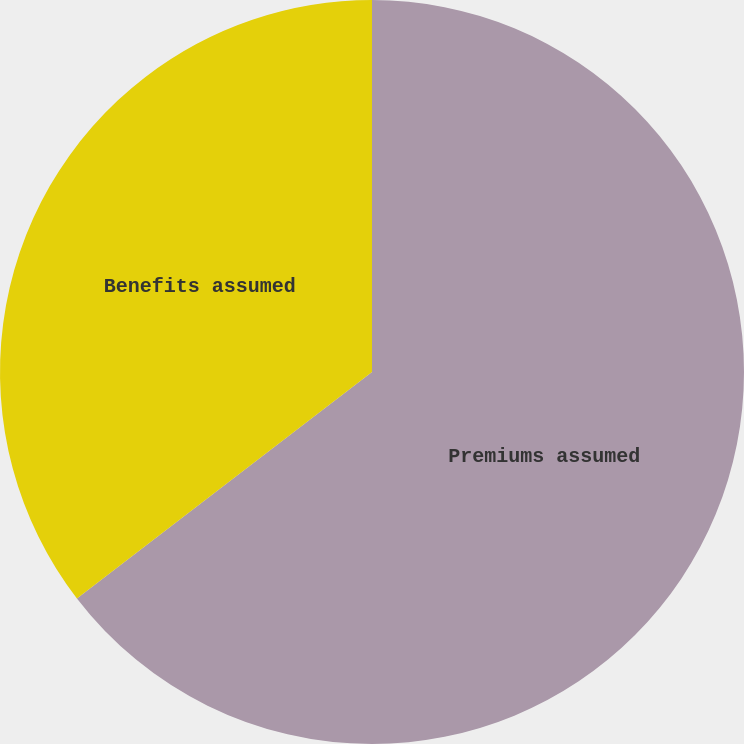Convert chart. <chart><loc_0><loc_0><loc_500><loc_500><pie_chart><fcel>Premiums assumed<fcel>Benefits assumed<nl><fcel>64.58%<fcel>35.42%<nl></chart> 